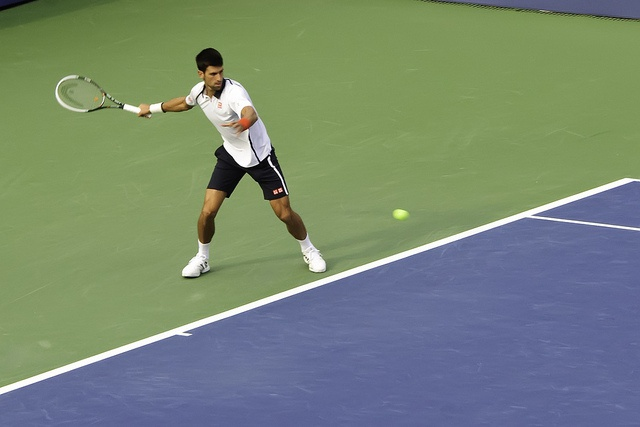Describe the objects in this image and their specific colors. I can see people in black, white, darkgray, and tan tones, tennis racket in black, olive, and ivory tones, and sports ball in black, olive, lightgreen, and khaki tones in this image. 